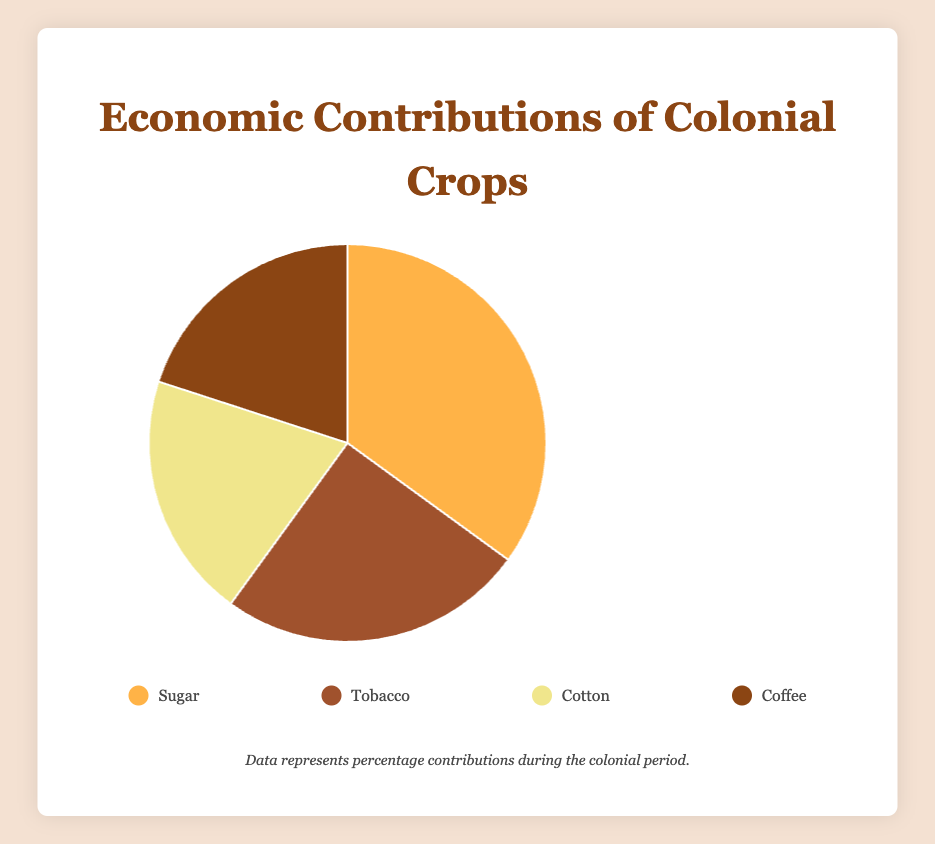Which crop has the highest economic contribution? By examining the pie chart, it is clear that the slice representing 'Sugar' takes up the largest portion of the pie, indicating the highest percentage contribution.
Answer: Sugar What total percentage do Coffee and Cotton contribute together? The respective contributions of Coffee and Cotton are 20% each. Adding them together: 20% + 20% = 40%.
Answer: 40% Which crop has a lower economic contribution: Tobacco or Coffee? By comparing the size of the slices, Tobacco contributes 25% and Coffee contributes 20%. Therefore, Coffee has a lower economic contribution.
Answer: Coffee How much greater is the economic contribution of Sugar compared to Tobacco? Sugar contributes 35%, and Tobacco contributes 25%. Subtracting the smaller contribution from the larger: 35% - 25% = 10%.
Answer: 10% What is the total economic contribution of the three least contributing crops? The three least contributing crops are Tobacco (25%), Cotton (20%), and Coffee (20%). Summing these: 25% + 20% + 20% = 65%.
Answer: 65% What crop represents 25% of the economic contributions? By looking at the pie chart, the portion representing 25% is the slice for 'Tobacco'.
Answer: Tobacco Which two crops have equal economic contribution percentages? The pie chart shows that both Cotton and Coffee have slices of equal size, each representing 20%.
Answer: Cotton and Coffee What is the average economic contribution of all four crops? Adding up all the percentages: 35% (Sugar) + 25% (Tobacco) + 20% (Cotton) + 20% (Coffee) = 100%. Dividing by the number of crops: 100% / 4 = 25%.
Answer: 25% Which slice on the pie chart is depicted with the lightest color? Observing the chart, the lightest-colored slice represents 'Sugar'.
Answer: Sugar 